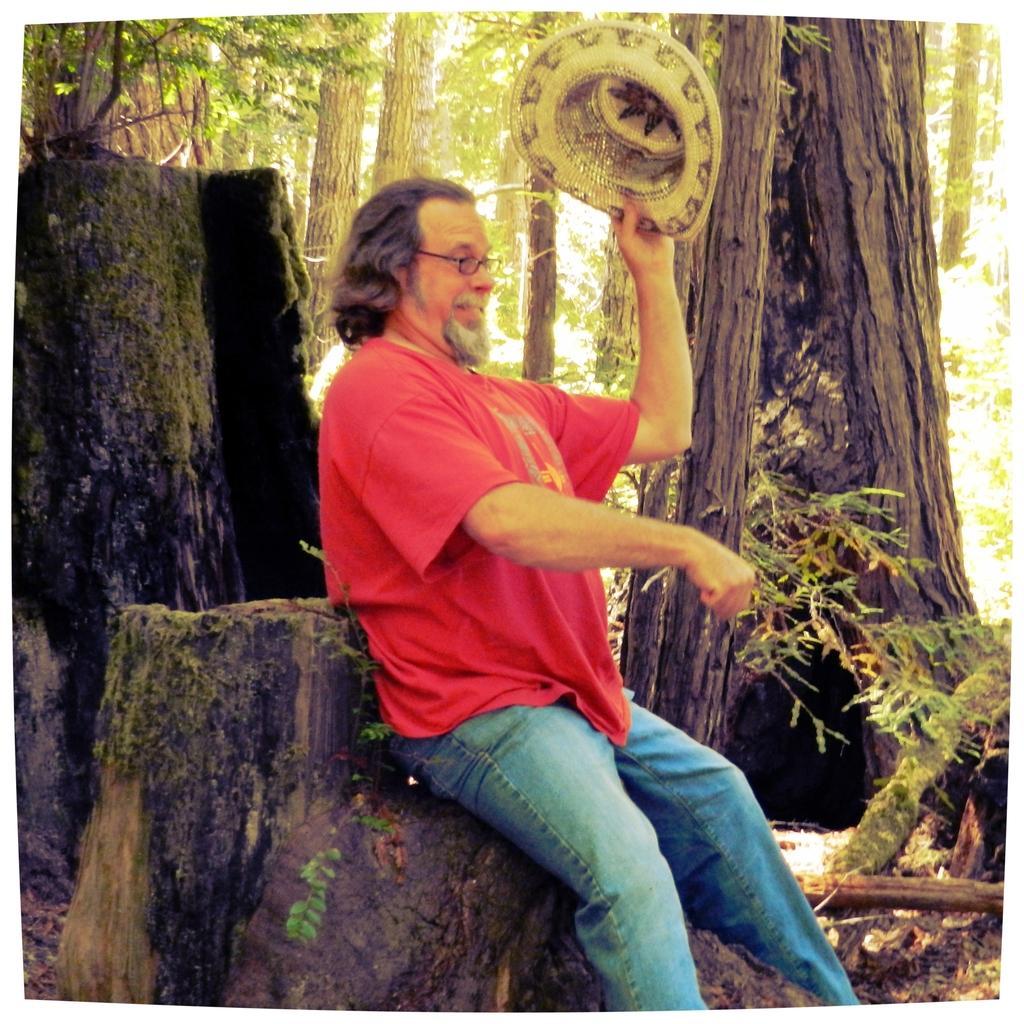In one or two sentences, can you explain what this image depicts? In this image there is a man sitting on a trunk facing towards the right side. This person is holding a cap in the hand. In the background there are many trees. 